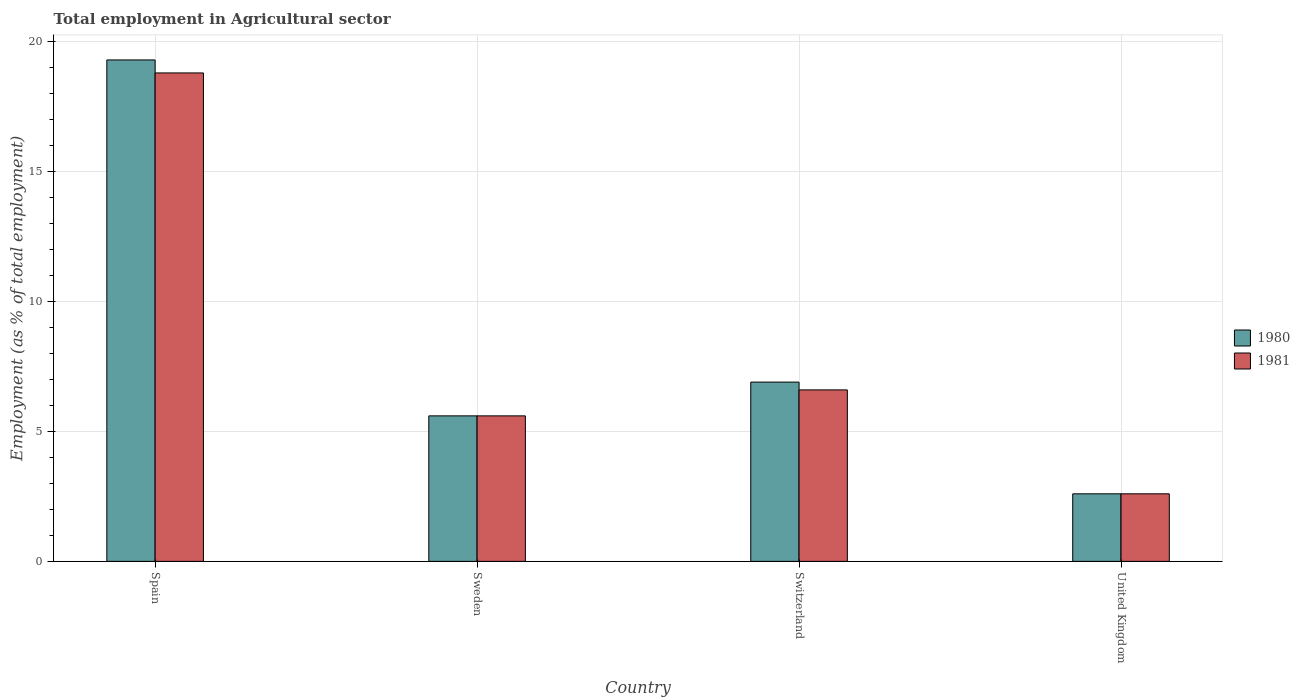Are the number of bars per tick equal to the number of legend labels?
Ensure brevity in your answer.  Yes. How many bars are there on the 1st tick from the right?
Offer a terse response. 2. What is the label of the 1st group of bars from the left?
Make the answer very short. Spain. In how many cases, is the number of bars for a given country not equal to the number of legend labels?
Your answer should be compact. 0. What is the employment in agricultural sector in 1981 in United Kingdom?
Keep it short and to the point. 2.6. Across all countries, what is the maximum employment in agricultural sector in 1981?
Your response must be concise. 18.8. Across all countries, what is the minimum employment in agricultural sector in 1981?
Your answer should be compact. 2.6. In which country was the employment in agricultural sector in 1980 minimum?
Ensure brevity in your answer.  United Kingdom. What is the total employment in agricultural sector in 1980 in the graph?
Keep it short and to the point. 34.4. What is the difference between the employment in agricultural sector in 1980 in Sweden and that in United Kingdom?
Make the answer very short. 3. What is the difference between the employment in agricultural sector in 1981 in Sweden and the employment in agricultural sector in 1980 in Spain?
Provide a short and direct response. -13.7. What is the average employment in agricultural sector in 1981 per country?
Provide a short and direct response. 8.4. What is the difference between the employment in agricultural sector of/in 1981 and employment in agricultural sector of/in 1980 in Switzerland?
Provide a short and direct response. -0.3. In how many countries, is the employment in agricultural sector in 1980 greater than 8 %?
Make the answer very short. 1. What is the ratio of the employment in agricultural sector in 1980 in Sweden to that in Switzerland?
Make the answer very short. 0.81. What is the difference between the highest and the second highest employment in agricultural sector in 1980?
Your answer should be compact. 13.7. What is the difference between the highest and the lowest employment in agricultural sector in 1980?
Provide a succinct answer. 16.7. In how many countries, is the employment in agricultural sector in 1981 greater than the average employment in agricultural sector in 1981 taken over all countries?
Give a very brief answer. 1. Is the sum of the employment in agricultural sector in 1980 in Spain and United Kingdom greater than the maximum employment in agricultural sector in 1981 across all countries?
Ensure brevity in your answer.  Yes. What does the 2nd bar from the left in Sweden represents?
Provide a short and direct response. 1981. How many bars are there?
Give a very brief answer. 8. Are all the bars in the graph horizontal?
Your answer should be compact. No. How many countries are there in the graph?
Keep it short and to the point. 4. What is the difference between two consecutive major ticks on the Y-axis?
Give a very brief answer. 5. How many legend labels are there?
Your answer should be very brief. 2. How are the legend labels stacked?
Your answer should be compact. Vertical. What is the title of the graph?
Your answer should be very brief. Total employment in Agricultural sector. What is the label or title of the Y-axis?
Provide a succinct answer. Employment (as % of total employment). What is the Employment (as % of total employment) of 1980 in Spain?
Your answer should be very brief. 19.3. What is the Employment (as % of total employment) of 1981 in Spain?
Give a very brief answer. 18.8. What is the Employment (as % of total employment) of 1980 in Sweden?
Offer a terse response. 5.6. What is the Employment (as % of total employment) of 1981 in Sweden?
Offer a very short reply. 5.6. What is the Employment (as % of total employment) in 1980 in Switzerland?
Your answer should be compact. 6.9. What is the Employment (as % of total employment) of 1981 in Switzerland?
Keep it short and to the point. 6.6. What is the Employment (as % of total employment) of 1980 in United Kingdom?
Your answer should be compact. 2.6. What is the Employment (as % of total employment) of 1981 in United Kingdom?
Give a very brief answer. 2.6. Across all countries, what is the maximum Employment (as % of total employment) in 1980?
Keep it short and to the point. 19.3. Across all countries, what is the maximum Employment (as % of total employment) in 1981?
Give a very brief answer. 18.8. Across all countries, what is the minimum Employment (as % of total employment) of 1980?
Offer a terse response. 2.6. Across all countries, what is the minimum Employment (as % of total employment) in 1981?
Offer a very short reply. 2.6. What is the total Employment (as % of total employment) of 1980 in the graph?
Your answer should be compact. 34.4. What is the total Employment (as % of total employment) of 1981 in the graph?
Your answer should be very brief. 33.6. What is the difference between the Employment (as % of total employment) in 1980 in Spain and that in Sweden?
Offer a very short reply. 13.7. What is the difference between the Employment (as % of total employment) of 1981 in Spain and that in Sweden?
Make the answer very short. 13.2. What is the difference between the Employment (as % of total employment) of 1980 in Spain and that in Switzerland?
Ensure brevity in your answer.  12.4. What is the difference between the Employment (as % of total employment) of 1980 in Spain and that in United Kingdom?
Your answer should be very brief. 16.7. What is the difference between the Employment (as % of total employment) in 1981 in Sweden and that in Switzerland?
Your answer should be very brief. -1. What is the difference between the Employment (as % of total employment) in 1980 in Sweden and that in United Kingdom?
Your response must be concise. 3. What is the difference between the Employment (as % of total employment) of 1980 in Switzerland and that in United Kingdom?
Offer a very short reply. 4.3. What is the difference between the Employment (as % of total employment) of 1981 in Switzerland and that in United Kingdom?
Your answer should be compact. 4. What is the difference between the Employment (as % of total employment) in 1980 in Spain and the Employment (as % of total employment) in 1981 in United Kingdom?
Offer a very short reply. 16.7. What is the difference between the Employment (as % of total employment) in 1980 in Sweden and the Employment (as % of total employment) in 1981 in United Kingdom?
Provide a succinct answer. 3. What is the difference between the Employment (as % of total employment) of 1980 in Switzerland and the Employment (as % of total employment) of 1981 in United Kingdom?
Offer a very short reply. 4.3. What is the average Employment (as % of total employment) in 1980 per country?
Your answer should be very brief. 8.6. What is the average Employment (as % of total employment) in 1981 per country?
Give a very brief answer. 8.4. What is the difference between the Employment (as % of total employment) in 1980 and Employment (as % of total employment) in 1981 in Sweden?
Provide a short and direct response. 0. What is the difference between the Employment (as % of total employment) in 1980 and Employment (as % of total employment) in 1981 in Switzerland?
Ensure brevity in your answer.  0.3. What is the difference between the Employment (as % of total employment) of 1980 and Employment (as % of total employment) of 1981 in United Kingdom?
Give a very brief answer. 0. What is the ratio of the Employment (as % of total employment) in 1980 in Spain to that in Sweden?
Your answer should be compact. 3.45. What is the ratio of the Employment (as % of total employment) in 1981 in Spain to that in Sweden?
Your response must be concise. 3.36. What is the ratio of the Employment (as % of total employment) in 1980 in Spain to that in Switzerland?
Keep it short and to the point. 2.8. What is the ratio of the Employment (as % of total employment) of 1981 in Spain to that in Switzerland?
Keep it short and to the point. 2.85. What is the ratio of the Employment (as % of total employment) of 1980 in Spain to that in United Kingdom?
Give a very brief answer. 7.42. What is the ratio of the Employment (as % of total employment) of 1981 in Spain to that in United Kingdom?
Ensure brevity in your answer.  7.23. What is the ratio of the Employment (as % of total employment) in 1980 in Sweden to that in Switzerland?
Give a very brief answer. 0.81. What is the ratio of the Employment (as % of total employment) of 1981 in Sweden to that in Switzerland?
Give a very brief answer. 0.85. What is the ratio of the Employment (as % of total employment) of 1980 in Sweden to that in United Kingdom?
Your response must be concise. 2.15. What is the ratio of the Employment (as % of total employment) in 1981 in Sweden to that in United Kingdom?
Your answer should be very brief. 2.15. What is the ratio of the Employment (as % of total employment) of 1980 in Switzerland to that in United Kingdom?
Offer a very short reply. 2.65. What is the ratio of the Employment (as % of total employment) in 1981 in Switzerland to that in United Kingdom?
Your answer should be very brief. 2.54. What is the difference between the highest and the second highest Employment (as % of total employment) in 1980?
Offer a very short reply. 12.4. What is the difference between the highest and the second highest Employment (as % of total employment) in 1981?
Provide a succinct answer. 12.2. What is the difference between the highest and the lowest Employment (as % of total employment) in 1980?
Keep it short and to the point. 16.7. 